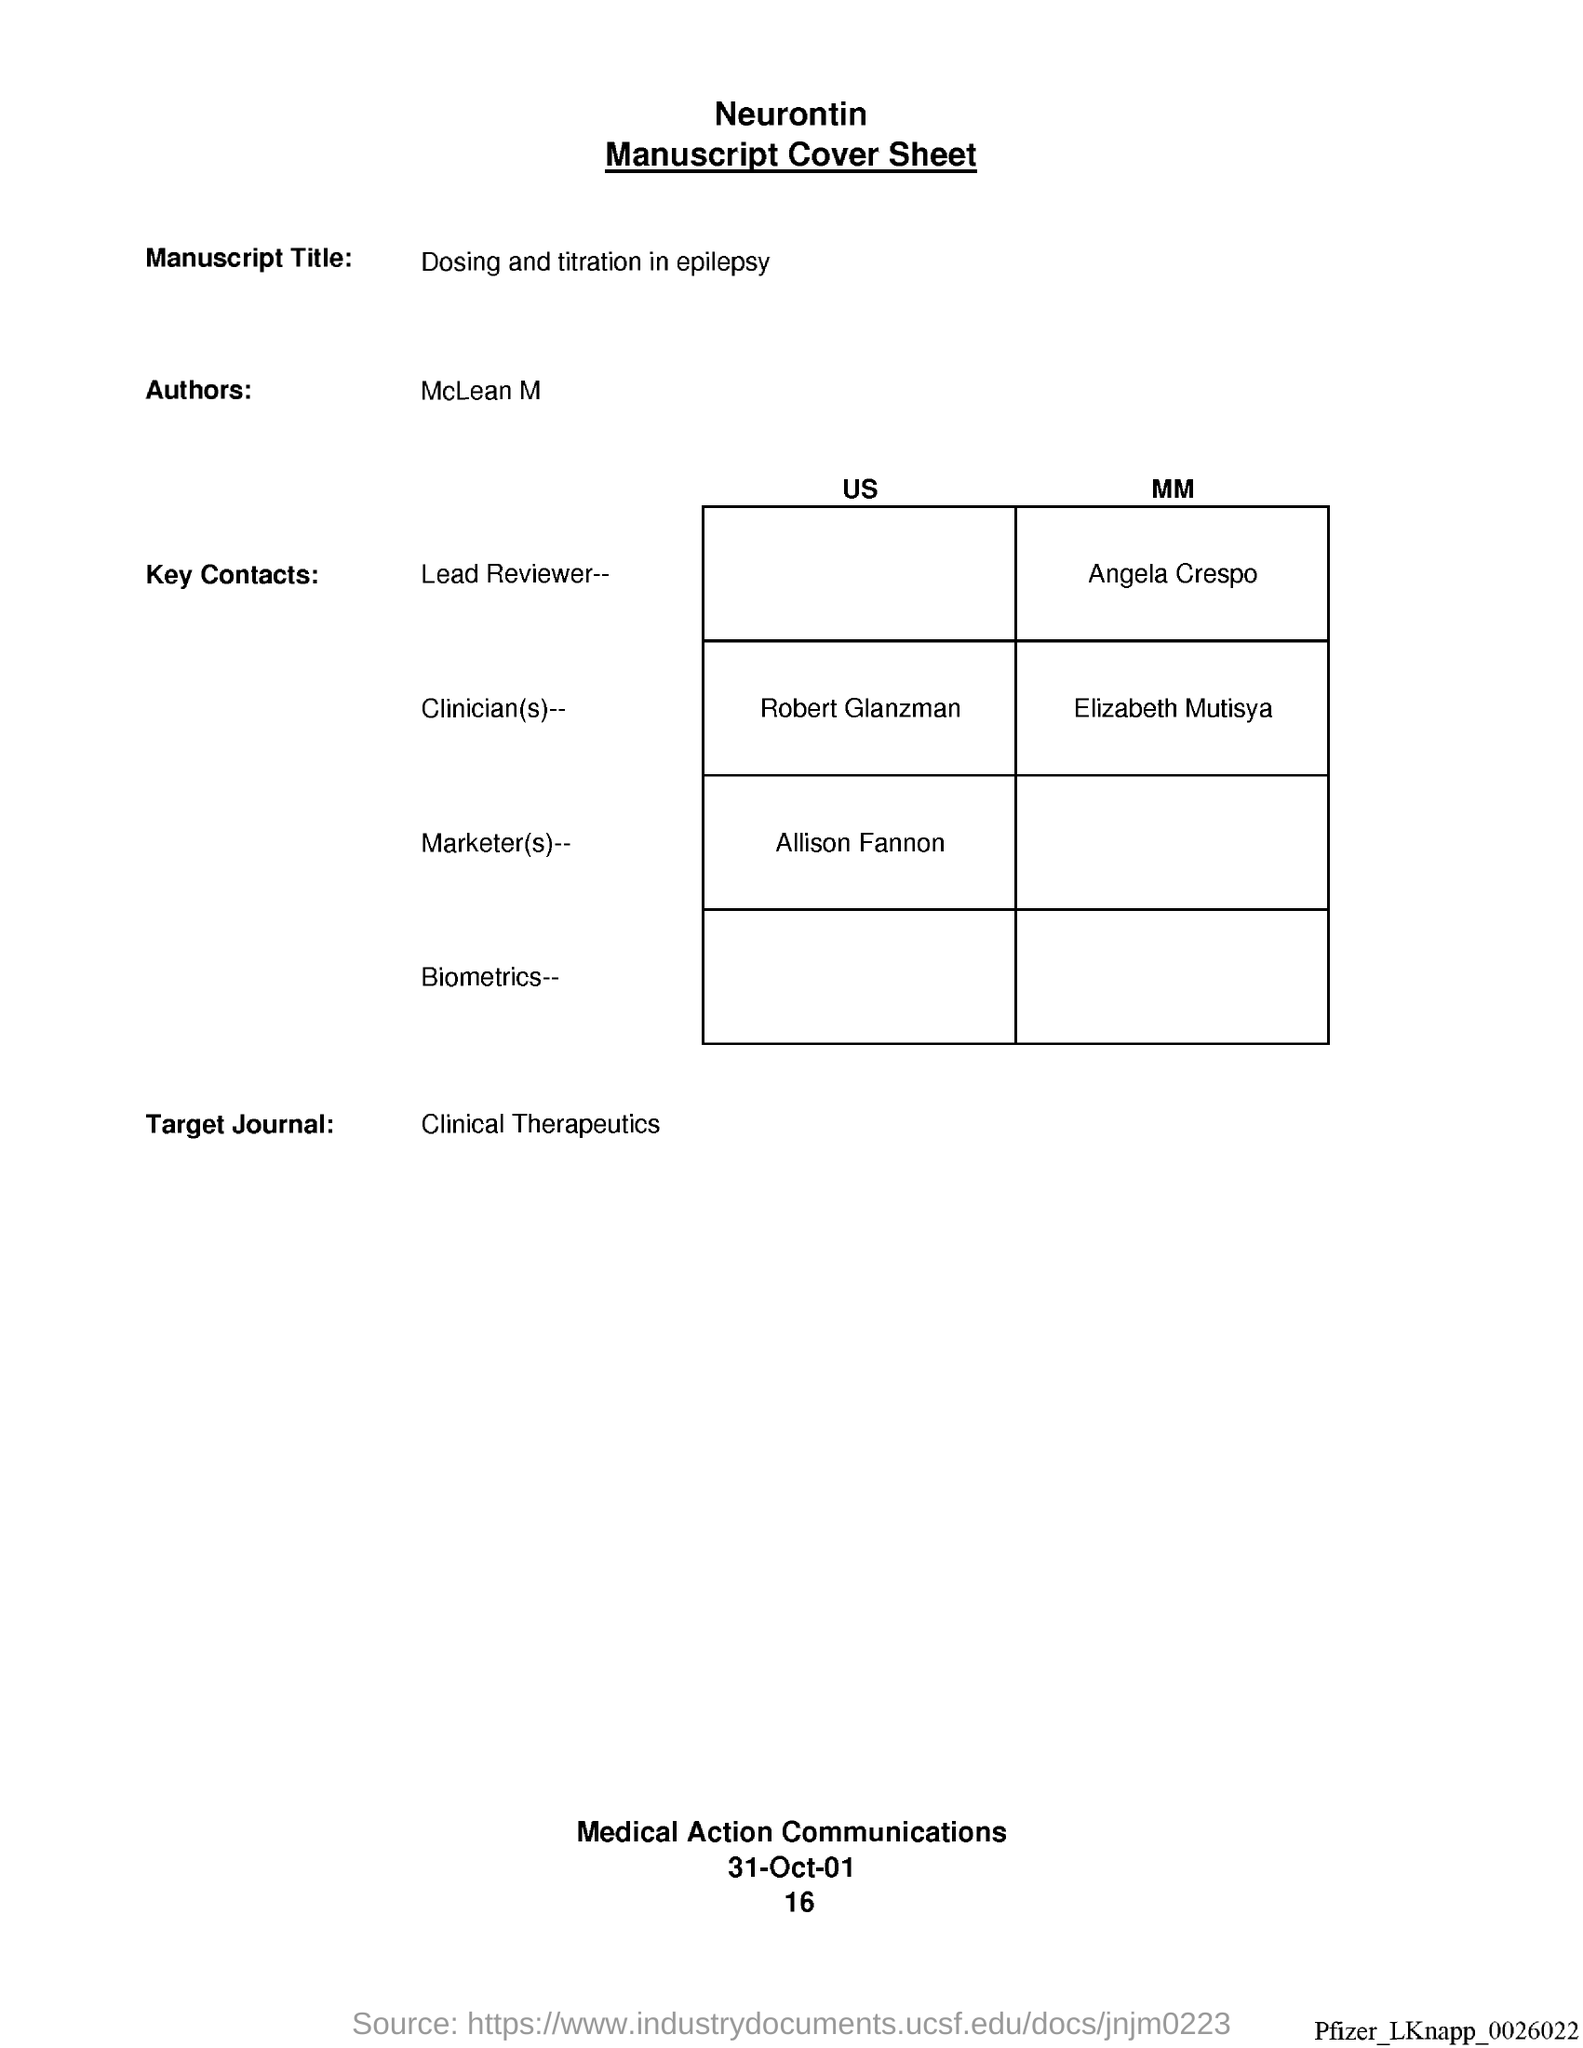What is the Manuscript Title?
Make the answer very short. Dosing and titration in epilepsy. Who is the Author?
Provide a short and direct response. McLean M. What is the Target Journal?
Provide a short and direct response. Clinical Therapeutics. What is the date?
Offer a terse response. 31-Oct-01. 